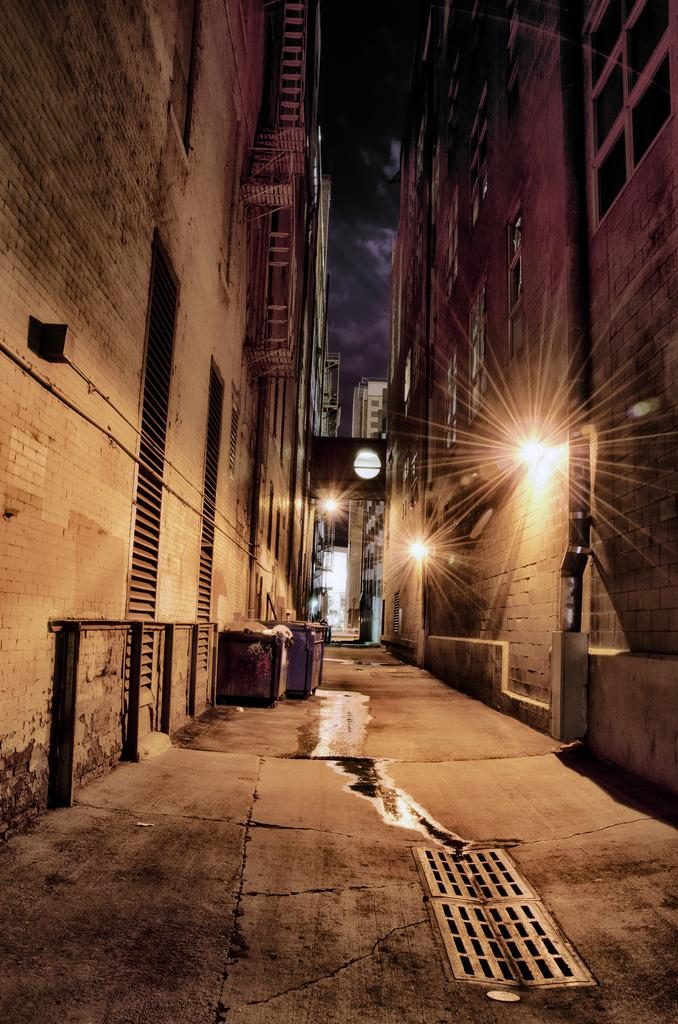What type of structures are present in the image? There are buildings in the image. What feature can be seen on the walls of the buildings? Lights are attached to the walls of the buildings. What objects are on the ground in the image? There are boxes on the ground. What can be seen in the background of the image? The sky is visible in the background of the image. What type of education can be seen being provided in the image? There is no indication of education being provided in the image; it primarily features buildings with lights and boxes on the ground. 